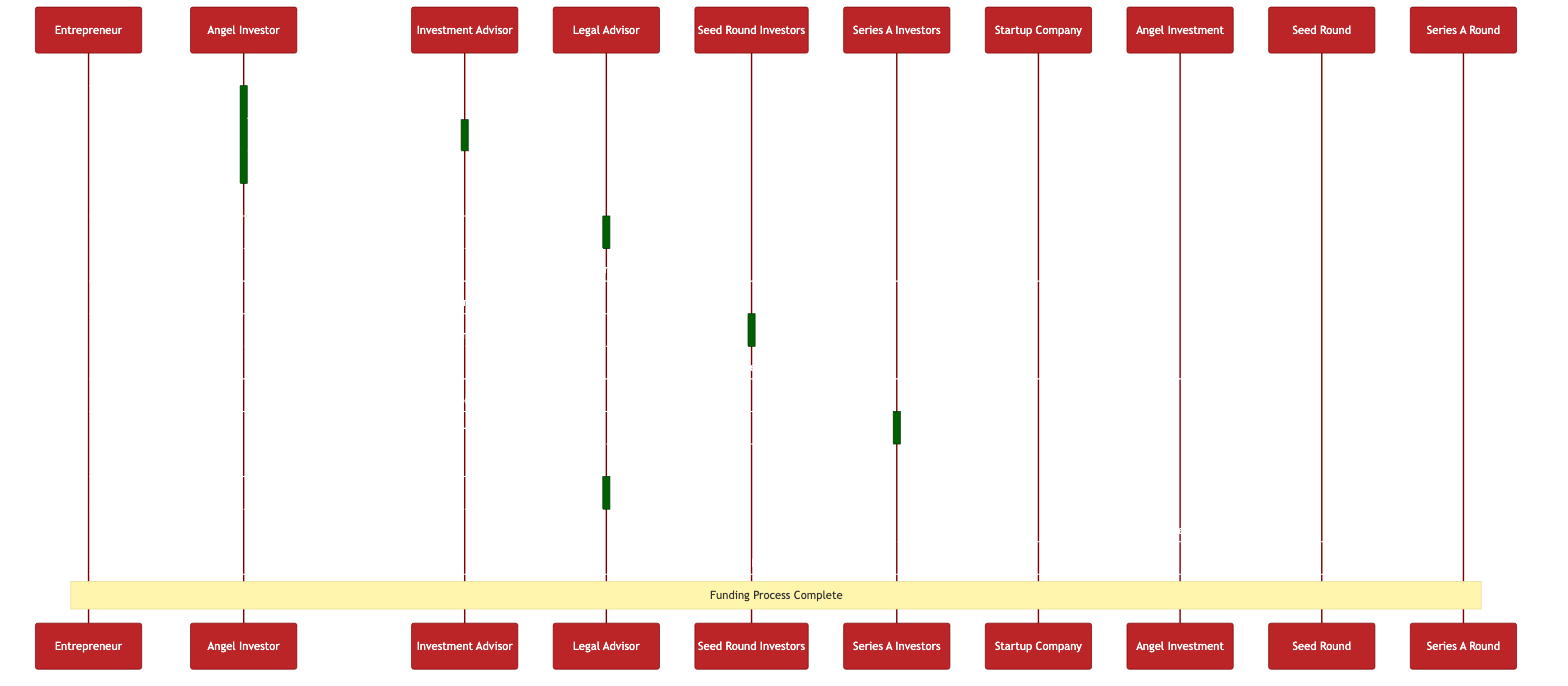What is the first message sent in the diagram? The first message in the diagram is sent from the Entrepreneur to the Angel Investor, with the content "Pitch Business Idea." This is the initiation of the funding process.
Answer: Pitch Business Idea How many actors are involved in the funding process? The diagram lists a total of six actors: Entrepreneur, Angel Investor, Investment Advisor, Legal Advisor, Seed Round Investors, and Series A Investors. Counting each one provides the total number.
Answer: Six What is the last action taken by the Entrepreneur? The last action taken by the Entrepreneur is to receive the Series A funding after the Series A investors provide funding. This is the completion of a significant phase in the funding process.
Answer: Series A Funding Received Which advisor provides the investment recommendation to the Angel Investor? The Investment Advisor evaluates the business viability and then provides the investment recommendation back to the Angel Investor. Thus, the Investment Advisor is the key actor in this step.
Answer: Investment Advisor What does the Entrepreneur do after receiving seed funding? After receiving the seed funding, the Entrepreneur indicates the receipt by sending a message stating "Seed Funding Received" to the Seed Round lifeline, which confirms that this funding has been successfully acquired.
Answer: Seed Funding Received What happens between the Series A Investors and the Entrepreneur right before the terms are negotiated? Just before the terms are negotiated, the Series A Investors offer a term sheet to the Entrepreneur. This step is crucial as it sets the foundation for the later negotiation of terms before funding is finalized.
Answer: Series A Term Sheet Offered How many distinct funding rounds are represented in the diagram? The diagram explicitly shows three funding rounds: Angel Investment, Seed Round, and Series A Round. Each of these rounds is represented by distinct lifelines in the sequence.
Answer: Three What is the role of the Legal Advisor in this process? The Legal Advisor plays a crucial role in drafting and finalizing the funding agreement. They assist the Entrepreneur in negotiating terms and ensuring that the agreements are in place before funding is received.
Answer: Draft Funding Agreement Which action signifies the completion of the funding process? The action that signifies the completion of the funding process is when the Entrepreneur receives the Series A Funding, as it represents the final step in this sequence of events leading up to Series A funding completion.
Answer: Funding Process Complete 